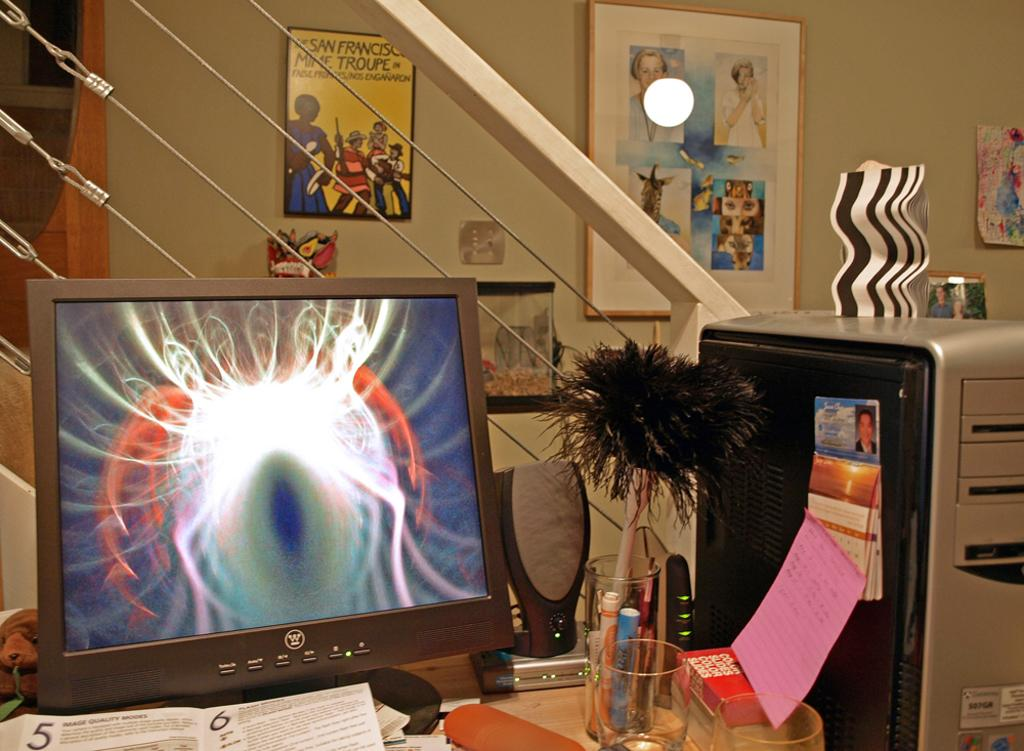Provide a one-sentence caption for the provided image. a laptop with an eyeball on the screen with the label 'w' on it. 